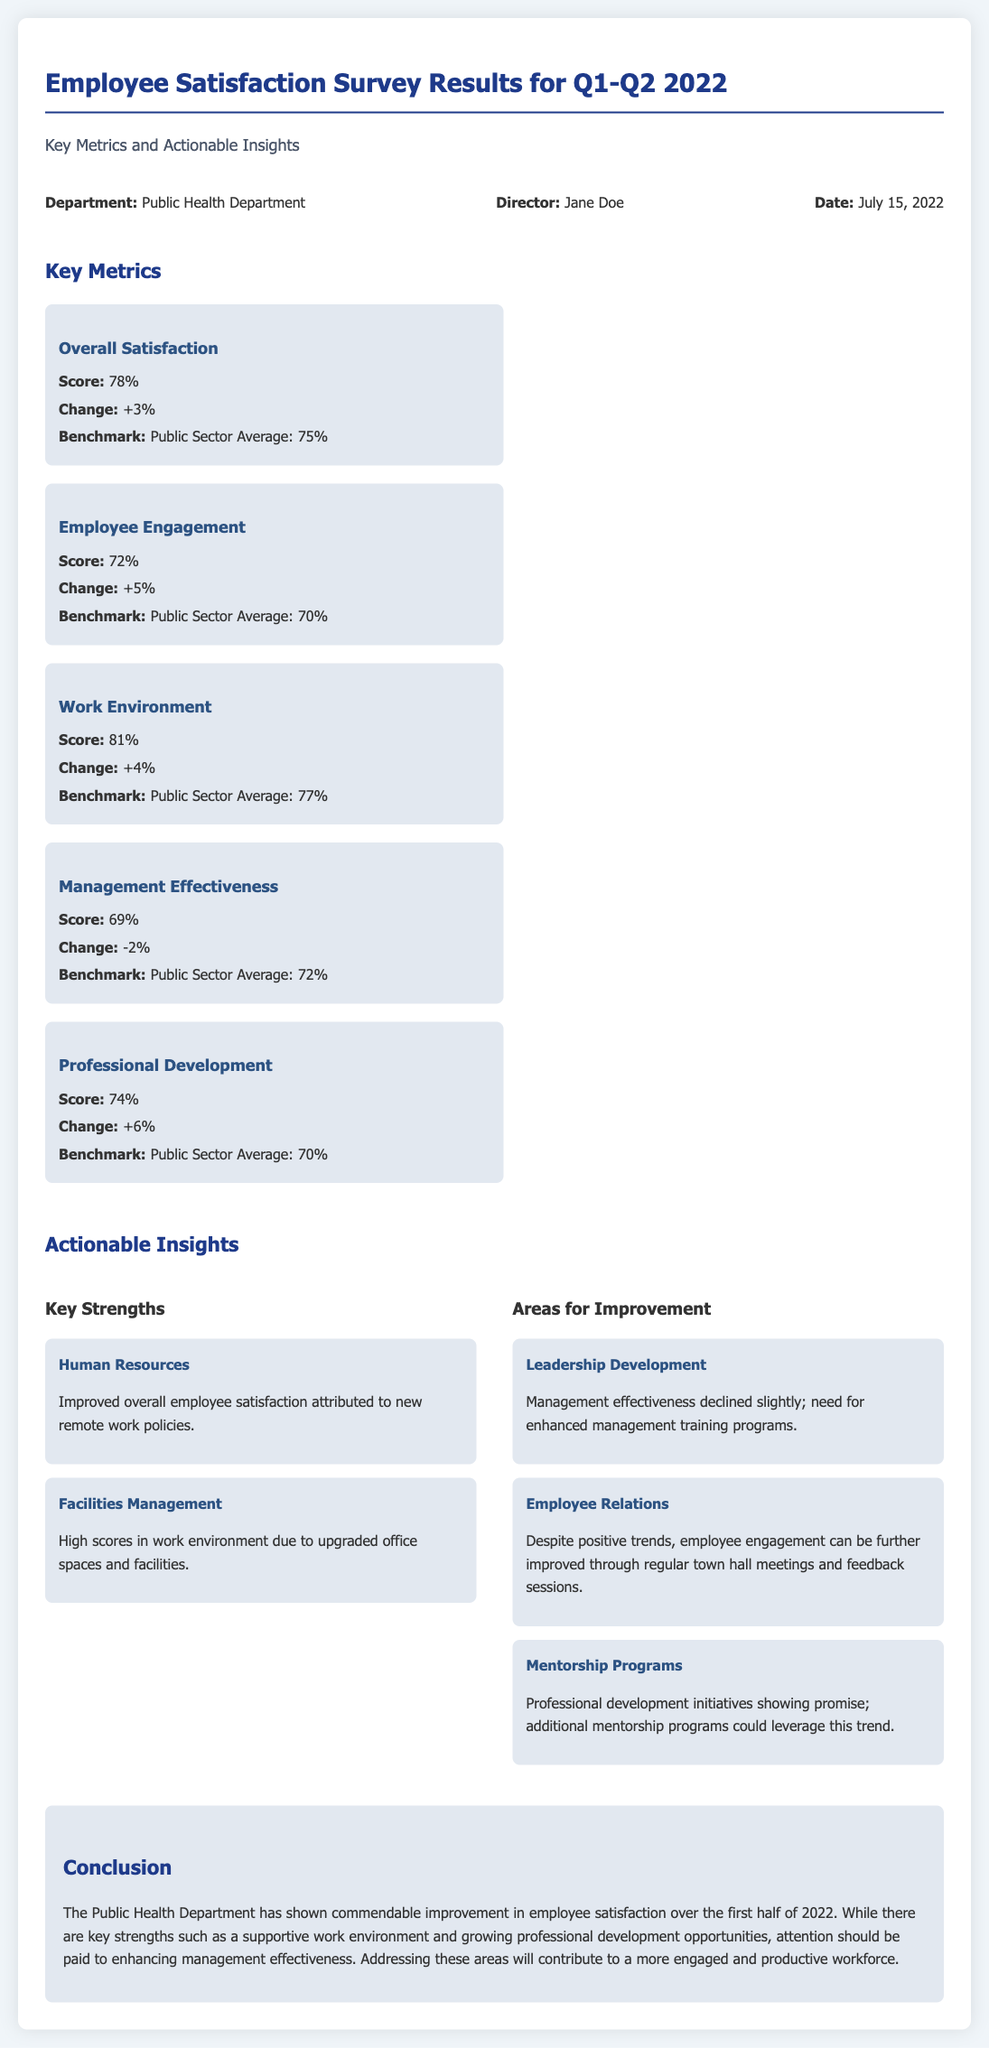What is the overall satisfaction score? The overall satisfaction score is directly stated in the document under Key Metrics.
Answer: 78% What is the management effectiveness score? The management effectiveness score is listed in the Key Metrics section.
Answer: 69% What percentage change in employee engagement was observed? The change in employee engagement can be found under Key Metrics.
Answer: +5% What department is this survey focused on? The title at the beginning mentions the specific department in focus.
Answer: Public Health Department What is the date of the report? The date of the report can be found in the information section of the document.
Answer: July 15, 2022 Which area had the highest score? The areas with scores can be compared to find the highest score listed in Key Metrics.
Answer: Work Environment What does the document suggest for improving management effectiveness? The document states what needs to be enhanced in terms of management training programs.
Answer: Management training programs How many actionable insights are mentioned? The document outlines the number of actionable insights provided throughout.
Answer: Five What is one key strength identified in the survey? Key strengths are highlighted in the Actionable Insights section, indicating a specific area.
Answer: Human Resources 